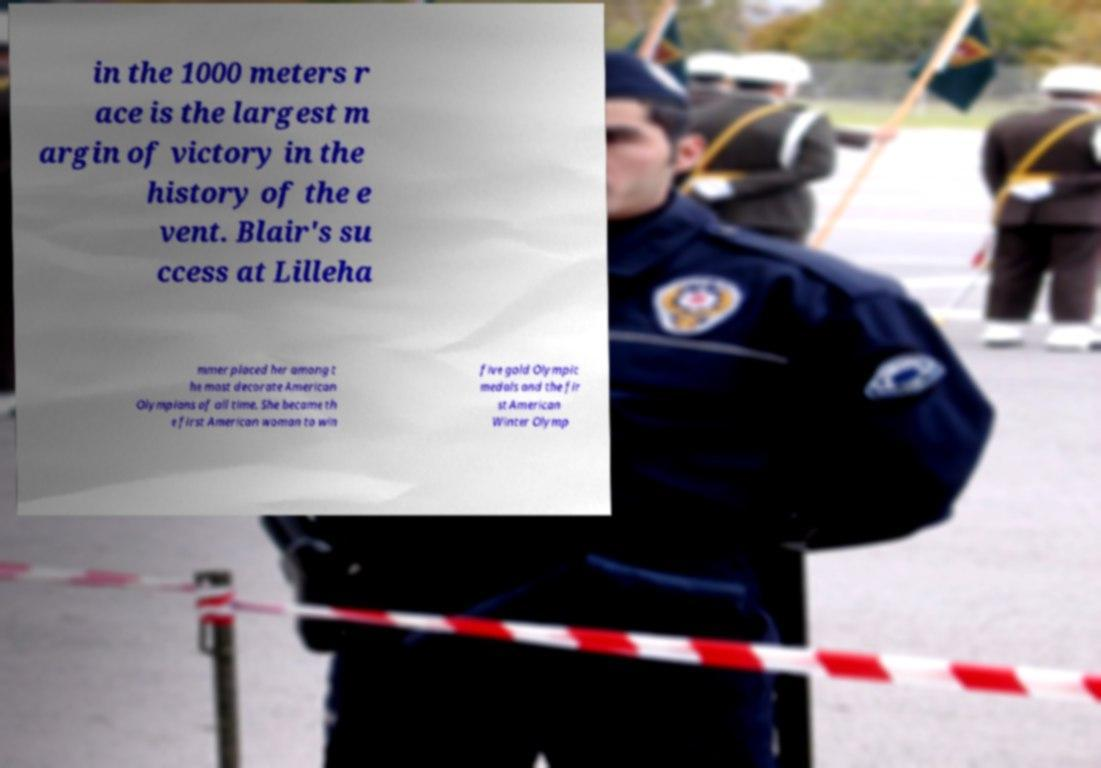What messages or text are displayed in this image? I need them in a readable, typed format. in the 1000 meters r ace is the largest m argin of victory in the history of the e vent. Blair's su ccess at Lilleha mmer placed her among t he most decorate American Olympians of all time. She became th e first American woman to win five gold Olympic medals and the fir st American Winter Olymp 